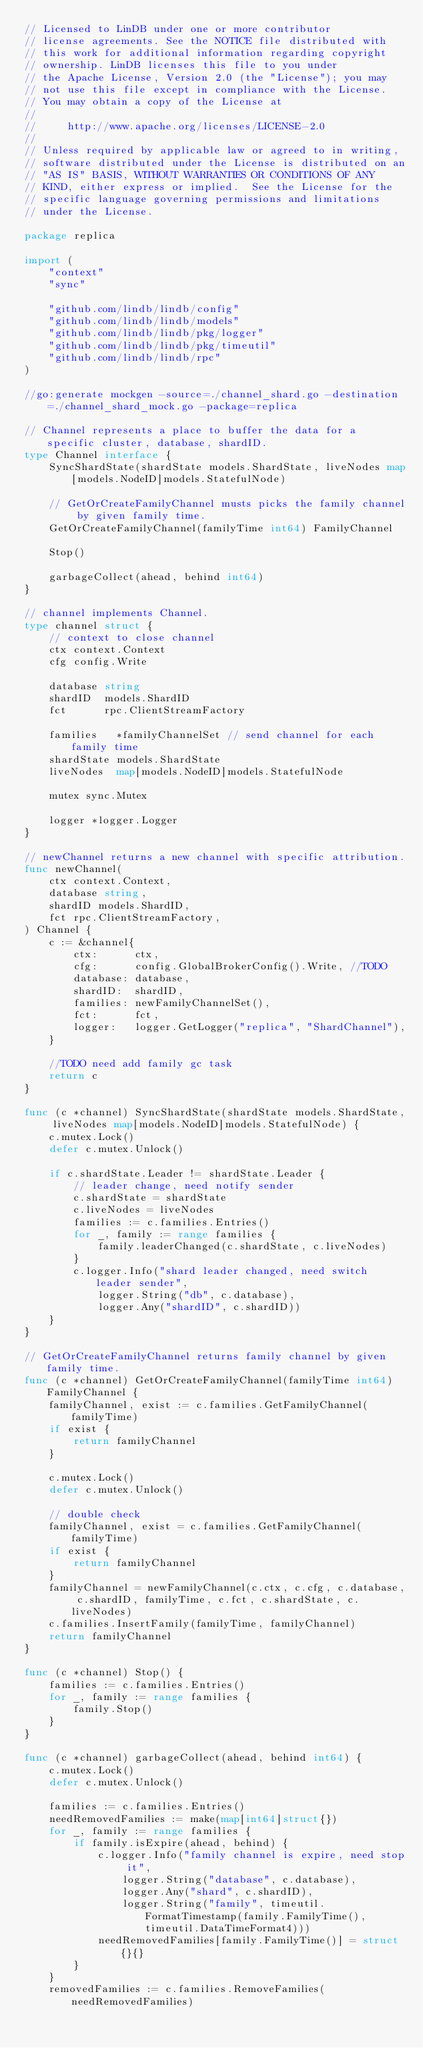<code> <loc_0><loc_0><loc_500><loc_500><_Go_>// Licensed to LinDB under one or more contributor
// license agreements. See the NOTICE file distributed with
// this work for additional information regarding copyright
// ownership. LinDB licenses this file to you under
// the Apache License, Version 2.0 (the "License"); you may
// not use this file except in compliance with the License.
// You may obtain a copy of the License at
//
//     http://www.apache.org/licenses/LICENSE-2.0
//
// Unless required by applicable law or agreed to in writing,
// software distributed under the License is distributed on an
// "AS IS" BASIS, WITHOUT WARRANTIES OR CONDITIONS OF ANY
// KIND, either express or implied.  See the License for the
// specific language governing permissions and limitations
// under the License.

package replica

import (
	"context"
	"sync"

	"github.com/lindb/lindb/config"
	"github.com/lindb/lindb/models"
	"github.com/lindb/lindb/pkg/logger"
	"github.com/lindb/lindb/pkg/timeutil"
	"github.com/lindb/lindb/rpc"
)

//go:generate mockgen -source=./channel_shard.go -destination=./channel_shard_mock.go -package=replica

// Channel represents a place to buffer the data for a specific cluster, database, shardID.
type Channel interface {
	SyncShardState(shardState models.ShardState, liveNodes map[models.NodeID]models.StatefulNode)

	// GetOrCreateFamilyChannel musts picks the family channel by given family time.
	GetOrCreateFamilyChannel(familyTime int64) FamilyChannel

	Stop()

	garbageCollect(ahead, behind int64)
}

// channel implements Channel.
type channel struct {
	// context to close channel
	ctx context.Context
	cfg config.Write

	database string
	shardID  models.ShardID
	fct      rpc.ClientStreamFactory

	families   *familyChannelSet // send channel for each family time
	shardState models.ShardState
	liveNodes  map[models.NodeID]models.StatefulNode

	mutex sync.Mutex

	logger *logger.Logger
}

// newChannel returns a new channel with specific attribution.
func newChannel(
	ctx context.Context,
	database string,
	shardID models.ShardID,
	fct rpc.ClientStreamFactory,
) Channel {
	c := &channel{
		ctx:      ctx,
		cfg:      config.GlobalBrokerConfig().Write, //TODO
		database: database,
		shardID:  shardID,
		families: newFamilyChannelSet(),
		fct:      fct,
		logger:   logger.GetLogger("replica", "ShardChannel"),
	}

	//TODO need add family gc task
	return c
}

func (c *channel) SyncShardState(shardState models.ShardState, liveNodes map[models.NodeID]models.StatefulNode) {
	c.mutex.Lock()
	defer c.mutex.Unlock()

	if c.shardState.Leader != shardState.Leader {
		// leader change, need notify sender
		c.shardState = shardState
		c.liveNodes = liveNodes
		families := c.families.Entries()
		for _, family := range families {
			family.leaderChanged(c.shardState, c.liveNodes)
		}
		c.logger.Info("shard leader changed, need switch leader sender",
			logger.String("db", c.database),
			logger.Any("shardID", c.shardID))
	}
}

// GetOrCreateFamilyChannel returns family channel by given family time.
func (c *channel) GetOrCreateFamilyChannel(familyTime int64) FamilyChannel {
	familyChannel, exist := c.families.GetFamilyChannel(familyTime)
	if exist {
		return familyChannel
	}

	c.mutex.Lock()
	defer c.mutex.Unlock()

	// double check
	familyChannel, exist = c.families.GetFamilyChannel(familyTime)
	if exist {
		return familyChannel
	}
	familyChannel = newFamilyChannel(c.ctx, c.cfg, c.database, c.shardID, familyTime, c.fct, c.shardState, c.liveNodes)
	c.families.InsertFamily(familyTime, familyChannel)
	return familyChannel
}

func (c *channel) Stop() {
	families := c.families.Entries()
	for _, family := range families {
		family.Stop()
	}
}

func (c *channel) garbageCollect(ahead, behind int64) {
	c.mutex.Lock()
	defer c.mutex.Unlock()

	families := c.families.Entries()
	needRemovedFamilies := make(map[int64]struct{})
	for _, family := range families {
		if family.isExpire(ahead, behind) {
			c.logger.Info("family channel is expire, need stop it",
				logger.String("database", c.database),
				logger.Any("shard", c.shardID),
				logger.String("family", timeutil.FormatTimestamp(family.FamilyTime(), timeutil.DataTimeFormat4)))
			needRemovedFamilies[family.FamilyTime()] = struct{}{}
		}
	}
	removedFamilies := c.families.RemoveFamilies(needRemovedFamilies)</code> 